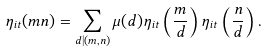Convert formula to latex. <formula><loc_0><loc_0><loc_500><loc_500>\eta _ { i t } ( m n ) = \sum _ { d | ( m , n ) } \mu ( d ) \eta _ { i t } \left ( \frac { m } { d } \right ) \eta _ { i t } \left ( \frac { n } { d } \right ) .</formula> 